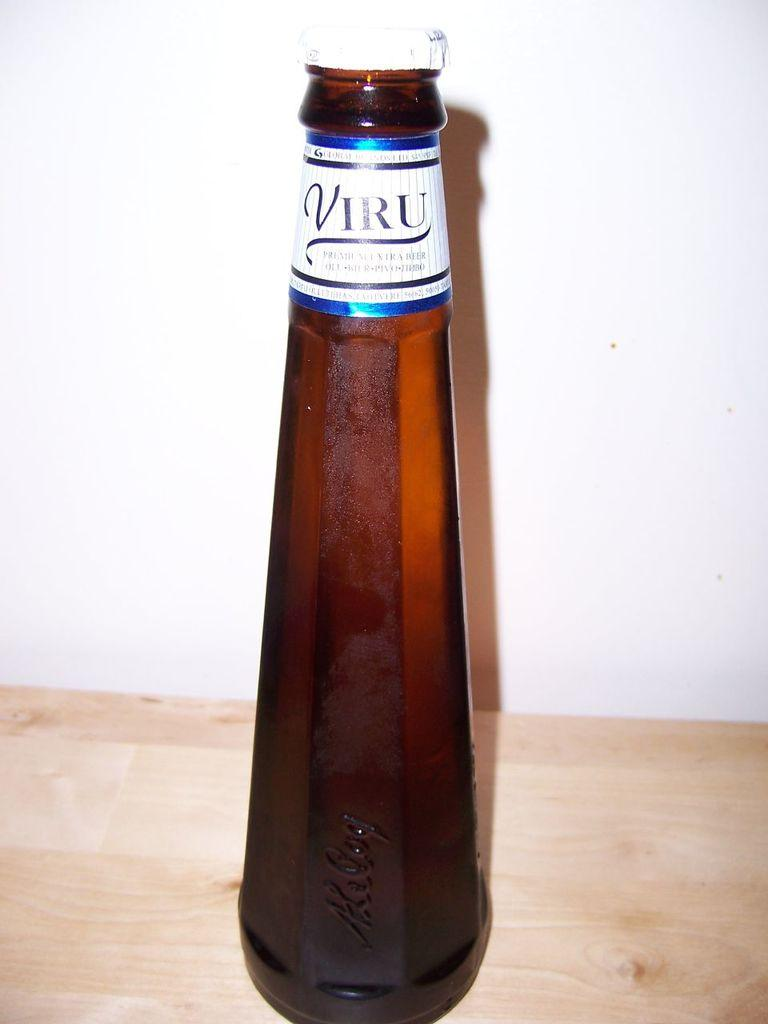<image>
Summarize the visual content of the image. A brown bottle has a label at the top that states Viru. 